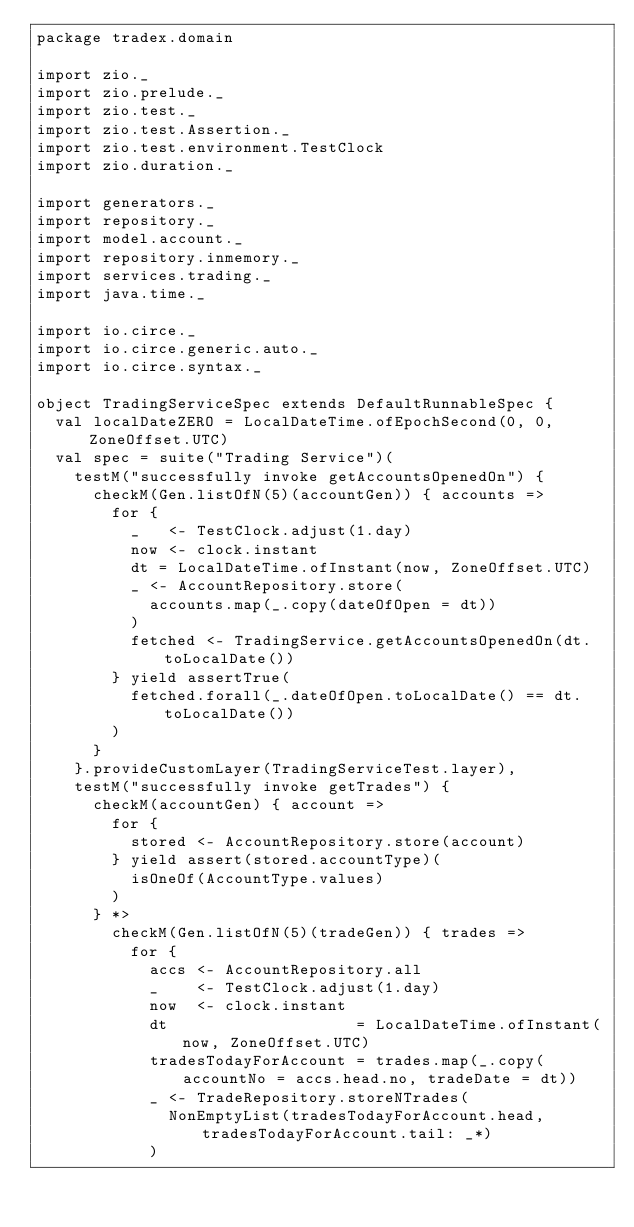<code> <loc_0><loc_0><loc_500><loc_500><_Scala_>package tradex.domain

import zio._
import zio.prelude._
import zio.test._
import zio.test.Assertion._
import zio.test.environment.TestClock
import zio.duration._

import generators._
import repository._
import model.account._
import repository.inmemory._
import services.trading._
import java.time._

import io.circe._
import io.circe.generic.auto._
import io.circe.syntax._

object TradingServiceSpec extends DefaultRunnableSpec {
  val localDateZERO = LocalDateTime.ofEpochSecond(0, 0, ZoneOffset.UTC)
  val spec = suite("Trading Service")(
    testM("successfully invoke getAccountsOpenedOn") {
      checkM(Gen.listOfN(5)(accountGen)) { accounts =>
        for {
          _   <- TestClock.adjust(1.day)
          now <- clock.instant
          dt = LocalDateTime.ofInstant(now, ZoneOffset.UTC)
          _ <- AccountRepository.store(
            accounts.map(_.copy(dateOfOpen = dt))
          )
          fetched <- TradingService.getAccountsOpenedOn(dt.toLocalDate())
        } yield assertTrue(
          fetched.forall(_.dateOfOpen.toLocalDate() == dt.toLocalDate())
        )
      }
    }.provideCustomLayer(TradingServiceTest.layer),
    testM("successfully invoke getTrades") {
      checkM(accountGen) { account =>
        for {
          stored <- AccountRepository.store(account)
        } yield assert(stored.accountType)(
          isOneOf(AccountType.values)
        )
      } *>
        checkM(Gen.listOfN(5)(tradeGen)) { trades =>
          for {
            accs <- AccountRepository.all
            _    <- TestClock.adjust(1.day)
            now  <- clock.instant
            dt                    = LocalDateTime.ofInstant(now, ZoneOffset.UTC)
            tradesTodayForAccount = trades.map(_.copy(accountNo = accs.head.no, tradeDate = dt))
            _ <- TradeRepository.storeNTrades(
              NonEmptyList(tradesTodayForAccount.head, tradesTodayForAccount.tail: _*)
            )</code> 